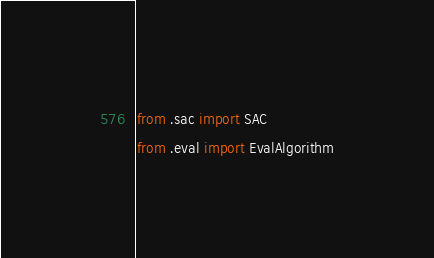<code> <loc_0><loc_0><loc_500><loc_500><_Python_>from .sac import SAC
from .eval import EvalAlgorithm
</code> 